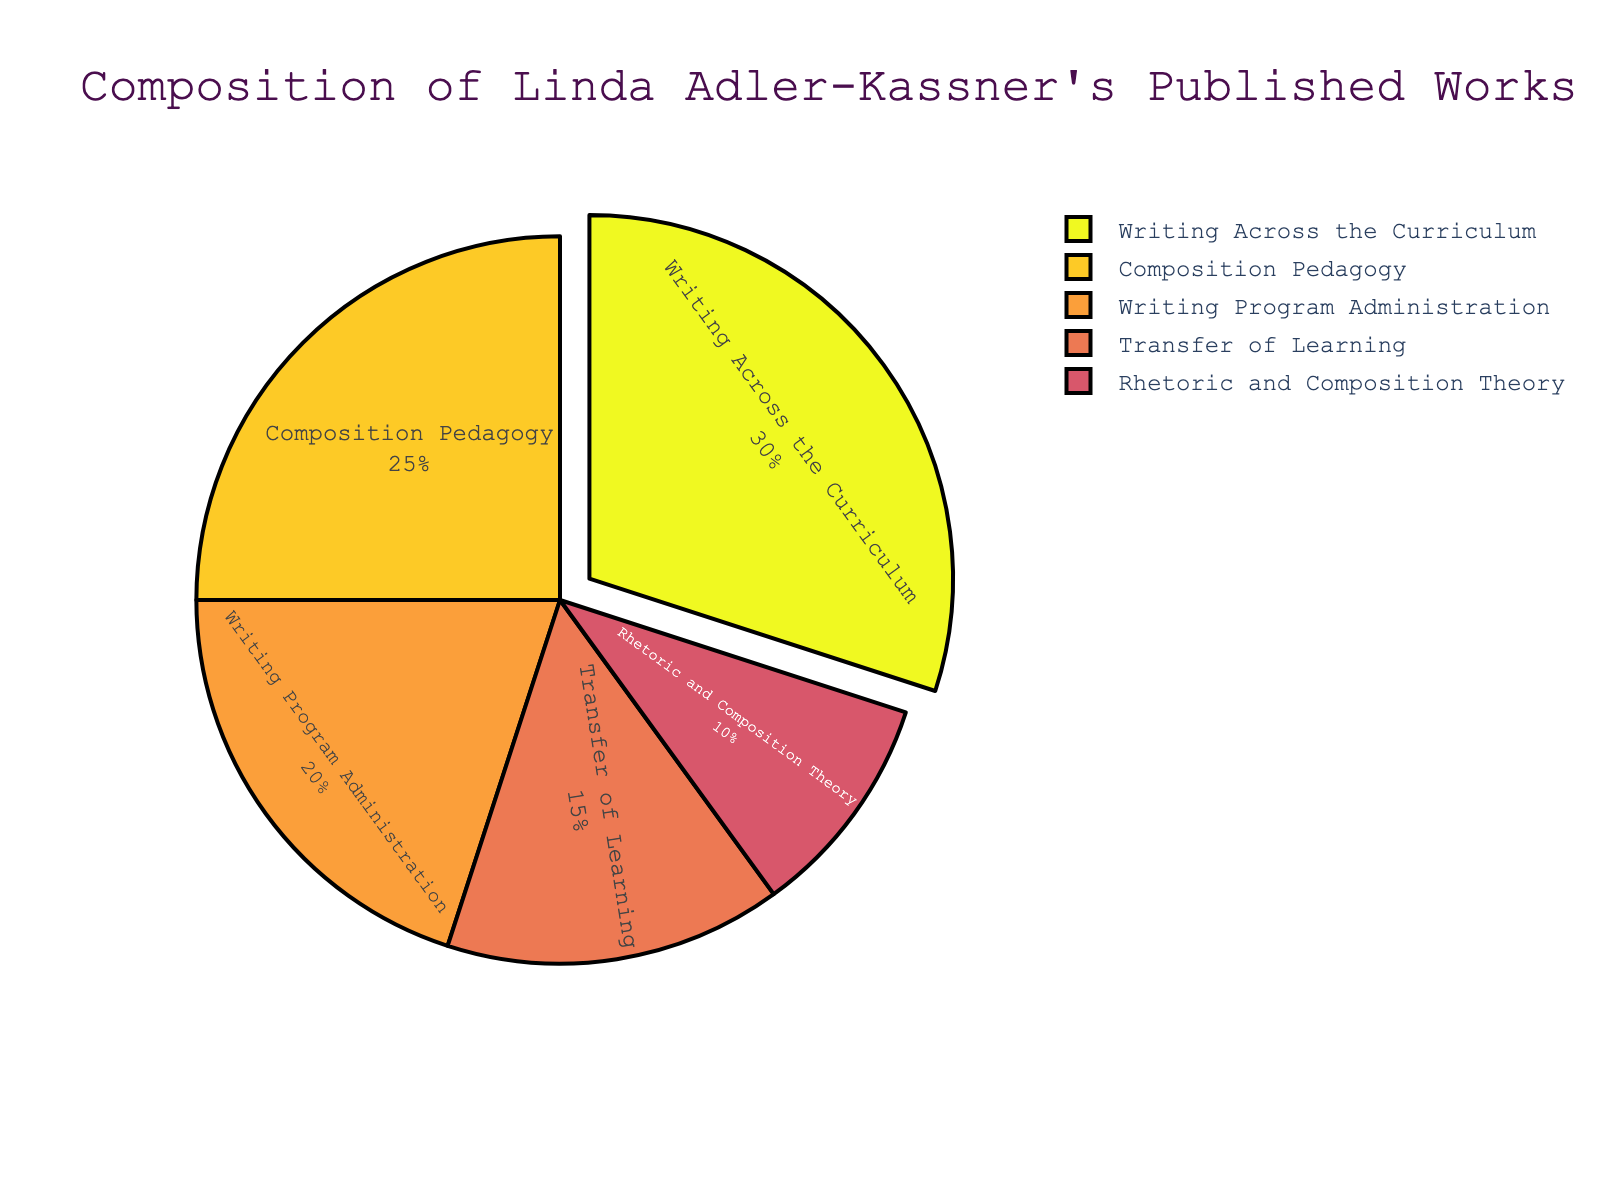Which subject area has the highest percentage in Linda Adler-Kassner's published works? The pie chart shows that "Writing Across the Curriculum" has the largest section.
Answer: Writing Across the Curriculum Among "Transfer of Learning" and "Writing Program Administration," which has a larger percentage and by how much? "Writing Program Administration" has 20%, and "Transfer of Learning" has 15%. The difference is 20% - 15% = 5%.
Answer: Writing Program Administration by 5% What is the total percentage of "Composition Pedagogy" and "Rhetoric and Composition Theory" combined? "Composition Pedagogy" contributes 25%, and "Rhetoric and Composition Theory" adds 10%. Summing these gives 25% + 10% = 35%.
Answer: 35% How much larger in percentage is "Writing Across the Curriculum" compared to "Composition Pedagogy"? "Writing Across the Curriculum" is 30%, while "Composition Pedagogy" is 25%. The difference is 30% - 25% = 5%.
Answer: 5% Rank the subject areas from highest to lowest percentage. The subject areas listed from highest to lowest are: "Writing Across the Curriculum" (30%), "Composition Pedagogy" (25%), "Writing Program Administration" (20%), "Transfer of Learning" (15%), "Rhetoric and Composition Theory" (10%).
Answer: Writing Across the Curriculum, Composition Pedagogy, Writing Program Administration, Transfer of Learning, Rhetoric and Composition Theory What is the average percentage of the top three subject areas? The top three subject areas are "Writing Across the Curriculum" (30%), "Composition Pedagogy" (25%), and "Writing Program Administration" (20%). The sum is 30% + 25% + 20% = 75%. The average is 75% / 3 = 25%.
Answer: 25% Is the percentage of "Rhetoric and Composition Theory" less than half of "Writing Program Administration"? "Rhetoric and Composition Theory" is 10%, and "Writing Program Administration" is 20%. Half of 20% is 10%, so 10% is equal to 10%.
Answer: No What color represents "Composition Pedagogy" in the pie chart? The pie chart uses a sequential color scheme. "Composition Pedagogy" is represented by a distinct color according to that sequence. Since the color specifics aren't in your visible data, but typically lighter variations appear in the middle of the sequence.
Answer: Middle color in the scheme Which subject areas together make up exactly 50% of the pie chart? Adding "Transfer of Learning" (15%) and "Writing Program Administration" (20%) gives 35%, adding "Rhetoric and Composition Theory" (10%) and "Composition Pedagogy" (25%) gives 35%. Therefore, combining "Transfer of Learning" (15%) and "Writing Across the Curriculum" (30%) yields 45%. Correctly adding "Composition Pedagogy" (25%) and "Transfer of Learning" (15%) equals 40%. Thus none add up to 50%.
Answer: None What is the difference in percentage between the largest and smallest subject areas? "Writing Across the Curriculum" has the highest at 30%, and "Rhetoric and Composition Theory" has the lowest at 10%. The difference is 30% - 10% = 20%.
Answer: 20% 